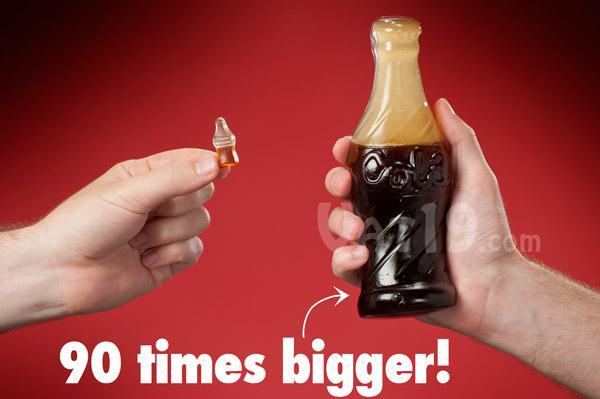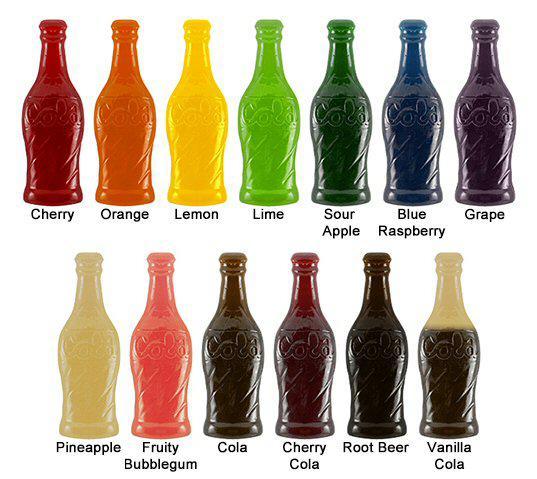The first image is the image on the left, the second image is the image on the right. Examine the images to the left and right. Is the description "One of the gummy sodas is orange." accurate? Answer yes or no. Yes. The first image is the image on the left, the second image is the image on the right. Analyze the images presented: Is the assertion "One image includes a silver-bladed knife and a bottle shape that is cut in two separated parts, and a hand is grasping a bottle that is not split in two parts in the other image." valid? Answer yes or no. No. 